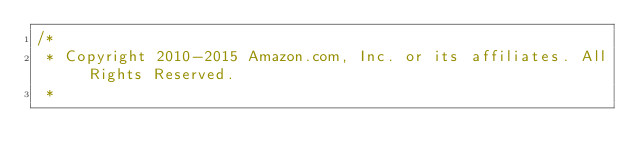Convert code to text. <code><loc_0><loc_0><loc_500><loc_500><_Java_>/*
 * Copyright 2010-2015 Amazon.com, Inc. or its affiliates. All Rights Reserved.
 *</code> 